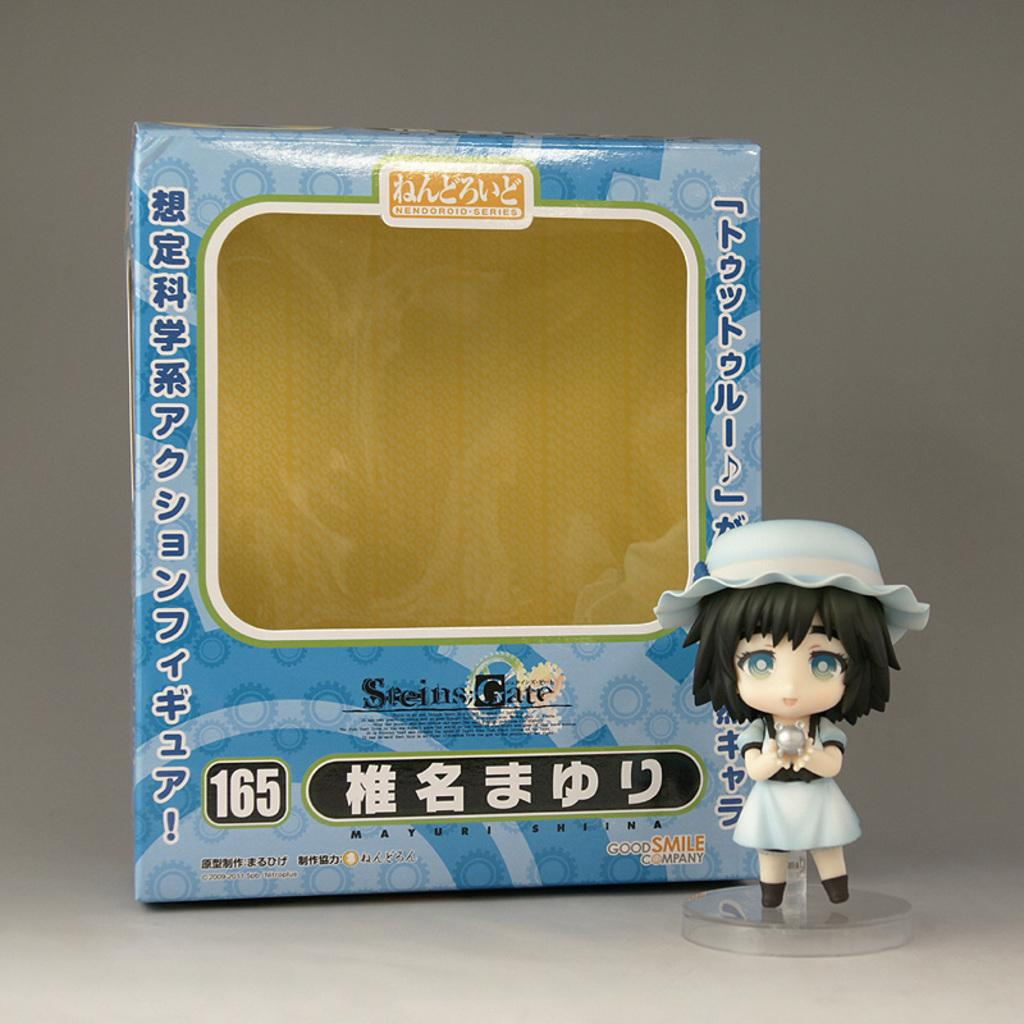What is located on the right side of the image? There is a doll on the right side of the image. What can be seen in the background of the image? There is a carton in the background of the image. How many dogs are playing with the bike in the image? There are no dogs or bikes present in the image. What type of engine can be seen powering the doll in the image? There is no engine present in the image, and the doll is not powered by any engine. 